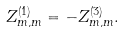Convert formula to latex. <formula><loc_0><loc_0><loc_500><loc_500>Z _ { m , m } ^ { ( 1 ) } = - Z ^ { ( 3 ) } _ { m , m } .</formula> 